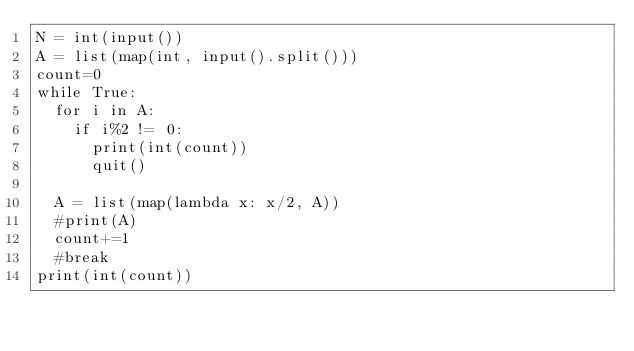<code> <loc_0><loc_0><loc_500><loc_500><_Python_>N = int(input())
A = list(map(int, input().split()))
count=0
while True:
  for i in A:
    if i%2 != 0:
      print(int(count))
      quit()
  
  A = list(map(lambda x: x/2, A))
  #print(A)
  count+=1
  #break
print(int(count))</code> 